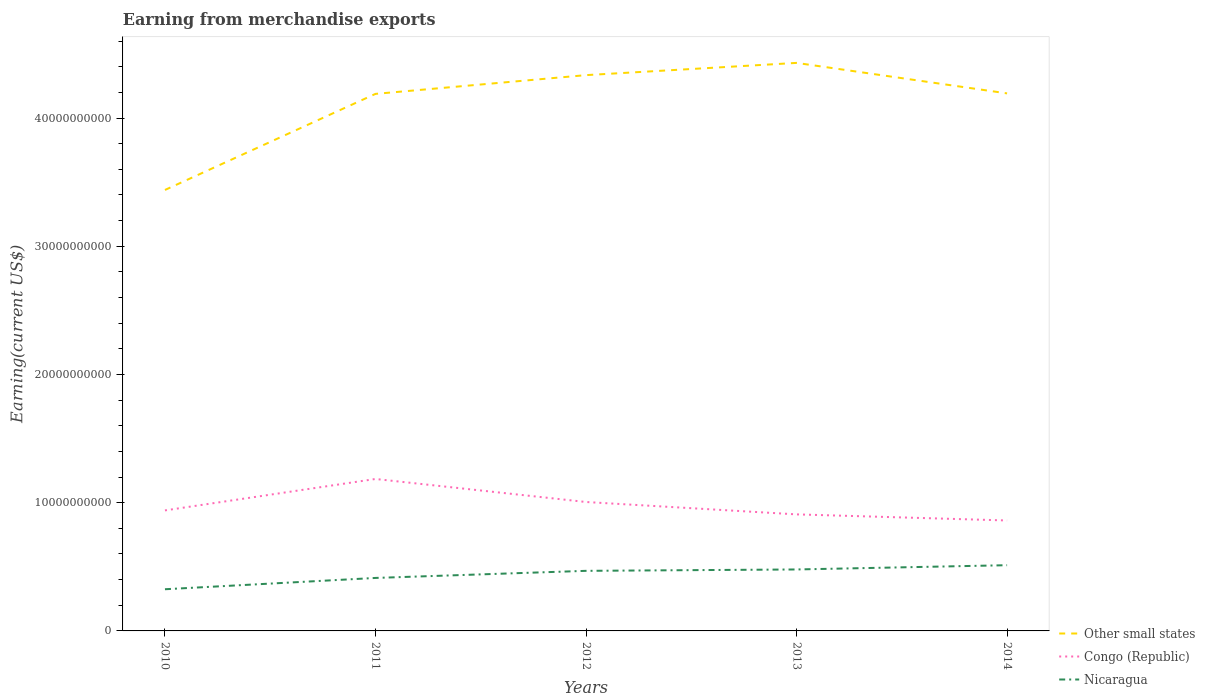How many different coloured lines are there?
Provide a short and direct response. 3. Does the line corresponding to Nicaragua intersect with the line corresponding to Congo (Republic)?
Your answer should be compact. No. Is the number of lines equal to the number of legend labels?
Offer a very short reply. Yes. Across all years, what is the maximum amount earned from merchandise exports in Nicaragua?
Provide a succinct answer. 3.25e+09. What is the total amount earned from merchandise exports in Nicaragua in the graph?
Give a very brief answer. -1.87e+09. What is the difference between the highest and the second highest amount earned from merchandise exports in Congo (Republic)?
Your answer should be very brief. 3.24e+09. Is the amount earned from merchandise exports in Congo (Republic) strictly greater than the amount earned from merchandise exports in Other small states over the years?
Make the answer very short. Yes. How many years are there in the graph?
Offer a very short reply. 5. What is the difference between two consecutive major ticks on the Y-axis?
Offer a very short reply. 1.00e+1. Are the values on the major ticks of Y-axis written in scientific E-notation?
Offer a very short reply. No. Does the graph contain any zero values?
Offer a very short reply. No. How many legend labels are there?
Make the answer very short. 3. How are the legend labels stacked?
Ensure brevity in your answer.  Vertical. What is the title of the graph?
Ensure brevity in your answer.  Earning from merchandise exports. Does "Bangladesh" appear as one of the legend labels in the graph?
Provide a short and direct response. No. What is the label or title of the Y-axis?
Make the answer very short. Earning(current US$). What is the Earning(current US$) in Other small states in 2010?
Provide a short and direct response. 3.44e+1. What is the Earning(current US$) of Congo (Republic) in 2010?
Make the answer very short. 9.40e+09. What is the Earning(current US$) of Nicaragua in 2010?
Keep it short and to the point. 3.25e+09. What is the Earning(current US$) of Other small states in 2011?
Keep it short and to the point. 4.19e+1. What is the Earning(current US$) in Congo (Republic) in 2011?
Provide a short and direct response. 1.19e+1. What is the Earning(current US$) of Nicaragua in 2011?
Give a very brief answer. 4.13e+09. What is the Earning(current US$) of Other small states in 2012?
Keep it short and to the point. 4.33e+1. What is the Earning(current US$) of Congo (Republic) in 2012?
Provide a short and direct response. 1.01e+1. What is the Earning(current US$) of Nicaragua in 2012?
Give a very brief answer. 4.69e+09. What is the Earning(current US$) in Other small states in 2013?
Your answer should be very brief. 4.43e+1. What is the Earning(current US$) in Congo (Republic) in 2013?
Your response must be concise. 9.09e+09. What is the Earning(current US$) in Nicaragua in 2013?
Make the answer very short. 4.79e+09. What is the Earning(current US$) in Other small states in 2014?
Give a very brief answer. 4.19e+1. What is the Earning(current US$) of Congo (Republic) in 2014?
Your answer should be very brief. 8.61e+09. What is the Earning(current US$) of Nicaragua in 2014?
Ensure brevity in your answer.  5.13e+09. Across all years, what is the maximum Earning(current US$) of Other small states?
Provide a short and direct response. 4.43e+1. Across all years, what is the maximum Earning(current US$) in Congo (Republic)?
Your answer should be compact. 1.19e+1. Across all years, what is the maximum Earning(current US$) in Nicaragua?
Your answer should be very brief. 5.13e+09. Across all years, what is the minimum Earning(current US$) of Other small states?
Keep it short and to the point. 3.44e+1. Across all years, what is the minimum Earning(current US$) of Congo (Republic)?
Keep it short and to the point. 8.61e+09. Across all years, what is the minimum Earning(current US$) of Nicaragua?
Provide a short and direct response. 3.25e+09. What is the total Earning(current US$) in Other small states in the graph?
Your response must be concise. 2.06e+11. What is the total Earning(current US$) in Congo (Republic) in the graph?
Provide a short and direct response. 4.90e+1. What is the total Earning(current US$) of Nicaragua in the graph?
Make the answer very short. 2.20e+1. What is the difference between the Earning(current US$) in Other small states in 2010 and that in 2011?
Offer a very short reply. -7.49e+09. What is the difference between the Earning(current US$) in Congo (Republic) in 2010 and that in 2011?
Your answer should be compact. -2.45e+09. What is the difference between the Earning(current US$) in Nicaragua in 2010 and that in 2011?
Your answer should be very brief. -8.82e+08. What is the difference between the Earning(current US$) of Other small states in 2010 and that in 2012?
Your response must be concise. -8.96e+09. What is the difference between the Earning(current US$) in Congo (Republic) in 2010 and that in 2012?
Make the answer very short. -6.55e+08. What is the difference between the Earning(current US$) of Nicaragua in 2010 and that in 2012?
Your answer should be very brief. -1.44e+09. What is the difference between the Earning(current US$) in Other small states in 2010 and that in 2013?
Your answer should be compact. -9.91e+09. What is the difference between the Earning(current US$) in Congo (Republic) in 2010 and that in 2013?
Your answer should be compact. 3.10e+08. What is the difference between the Earning(current US$) of Nicaragua in 2010 and that in 2013?
Offer a very short reply. -1.54e+09. What is the difference between the Earning(current US$) in Other small states in 2010 and that in 2014?
Keep it short and to the point. -7.53e+09. What is the difference between the Earning(current US$) in Congo (Republic) in 2010 and that in 2014?
Your answer should be compact. 7.86e+08. What is the difference between the Earning(current US$) of Nicaragua in 2010 and that in 2014?
Ensure brevity in your answer.  -1.87e+09. What is the difference between the Earning(current US$) of Other small states in 2011 and that in 2012?
Offer a very short reply. -1.46e+09. What is the difference between the Earning(current US$) in Congo (Republic) in 2011 and that in 2012?
Give a very brief answer. 1.80e+09. What is the difference between the Earning(current US$) of Nicaragua in 2011 and that in 2012?
Your response must be concise. -5.54e+08. What is the difference between the Earning(current US$) of Other small states in 2011 and that in 2013?
Your answer should be very brief. -2.42e+09. What is the difference between the Earning(current US$) in Congo (Republic) in 2011 and that in 2013?
Offer a very short reply. 2.76e+09. What is the difference between the Earning(current US$) in Nicaragua in 2011 and that in 2013?
Give a very brief answer. -6.61e+08. What is the difference between the Earning(current US$) in Other small states in 2011 and that in 2014?
Give a very brief answer. -3.86e+07. What is the difference between the Earning(current US$) of Congo (Republic) in 2011 and that in 2014?
Ensure brevity in your answer.  3.24e+09. What is the difference between the Earning(current US$) of Nicaragua in 2011 and that in 2014?
Ensure brevity in your answer.  -9.93e+08. What is the difference between the Earning(current US$) in Other small states in 2012 and that in 2013?
Your answer should be very brief. -9.54e+08. What is the difference between the Earning(current US$) in Congo (Republic) in 2012 and that in 2013?
Give a very brief answer. 9.65e+08. What is the difference between the Earning(current US$) of Nicaragua in 2012 and that in 2013?
Offer a very short reply. -1.08e+08. What is the difference between the Earning(current US$) of Other small states in 2012 and that in 2014?
Provide a short and direct response. 1.42e+09. What is the difference between the Earning(current US$) of Congo (Republic) in 2012 and that in 2014?
Provide a short and direct response. 1.44e+09. What is the difference between the Earning(current US$) in Nicaragua in 2012 and that in 2014?
Your answer should be very brief. -4.40e+08. What is the difference between the Earning(current US$) of Other small states in 2013 and that in 2014?
Provide a short and direct response. 2.38e+09. What is the difference between the Earning(current US$) of Congo (Republic) in 2013 and that in 2014?
Offer a terse response. 4.76e+08. What is the difference between the Earning(current US$) of Nicaragua in 2013 and that in 2014?
Your answer should be compact. -3.32e+08. What is the difference between the Earning(current US$) of Other small states in 2010 and the Earning(current US$) of Congo (Republic) in 2011?
Your response must be concise. 2.25e+1. What is the difference between the Earning(current US$) in Other small states in 2010 and the Earning(current US$) in Nicaragua in 2011?
Offer a very short reply. 3.03e+1. What is the difference between the Earning(current US$) in Congo (Republic) in 2010 and the Earning(current US$) in Nicaragua in 2011?
Make the answer very short. 5.27e+09. What is the difference between the Earning(current US$) of Other small states in 2010 and the Earning(current US$) of Congo (Republic) in 2012?
Offer a very short reply. 2.43e+1. What is the difference between the Earning(current US$) of Other small states in 2010 and the Earning(current US$) of Nicaragua in 2012?
Offer a terse response. 2.97e+1. What is the difference between the Earning(current US$) of Congo (Republic) in 2010 and the Earning(current US$) of Nicaragua in 2012?
Keep it short and to the point. 4.71e+09. What is the difference between the Earning(current US$) of Other small states in 2010 and the Earning(current US$) of Congo (Republic) in 2013?
Your answer should be compact. 2.53e+1. What is the difference between the Earning(current US$) of Other small states in 2010 and the Earning(current US$) of Nicaragua in 2013?
Your answer should be compact. 2.96e+1. What is the difference between the Earning(current US$) in Congo (Republic) in 2010 and the Earning(current US$) in Nicaragua in 2013?
Make the answer very short. 4.61e+09. What is the difference between the Earning(current US$) of Other small states in 2010 and the Earning(current US$) of Congo (Republic) in 2014?
Give a very brief answer. 2.58e+1. What is the difference between the Earning(current US$) in Other small states in 2010 and the Earning(current US$) in Nicaragua in 2014?
Provide a short and direct response. 2.93e+1. What is the difference between the Earning(current US$) in Congo (Republic) in 2010 and the Earning(current US$) in Nicaragua in 2014?
Give a very brief answer. 4.27e+09. What is the difference between the Earning(current US$) in Other small states in 2011 and the Earning(current US$) in Congo (Republic) in 2012?
Your response must be concise. 3.18e+1. What is the difference between the Earning(current US$) of Other small states in 2011 and the Earning(current US$) of Nicaragua in 2012?
Offer a very short reply. 3.72e+1. What is the difference between the Earning(current US$) in Congo (Republic) in 2011 and the Earning(current US$) in Nicaragua in 2012?
Offer a very short reply. 7.16e+09. What is the difference between the Earning(current US$) in Other small states in 2011 and the Earning(current US$) in Congo (Republic) in 2013?
Give a very brief answer. 3.28e+1. What is the difference between the Earning(current US$) of Other small states in 2011 and the Earning(current US$) of Nicaragua in 2013?
Give a very brief answer. 3.71e+1. What is the difference between the Earning(current US$) of Congo (Republic) in 2011 and the Earning(current US$) of Nicaragua in 2013?
Offer a terse response. 7.06e+09. What is the difference between the Earning(current US$) in Other small states in 2011 and the Earning(current US$) in Congo (Republic) in 2014?
Ensure brevity in your answer.  3.33e+1. What is the difference between the Earning(current US$) in Other small states in 2011 and the Earning(current US$) in Nicaragua in 2014?
Give a very brief answer. 3.68e+1. What is the difference between the Earning(current US$) in Congo (Republic) in 2011 and the Earning(current US$) in Nicaragua in 2014?
Your answer should be very brief. 6.73e+09. What is the difference between the Earning(current US$) in Other small states in 2012 and the Earning(current US$) in Congo (Republic) in 2013?
Keep it short and to the point. 3.43e+1. What is the difference between the Earning(current US$) in Other small states in 2012 and the Earning(current US$) in Nicaragua in 2013?
Make the answer very short. 3.86e+1. What is the difference between the Earning(current US$) in Congo (Republic) in 2012 and the Earning(current US$) in Nicaragua in 2013?
Ensure brevity in your answer.  5.26e+09. What is the difference between the Earning(current US$) of Other small states in 2012 and the Earning(current US$) of Congo (Republic) in 2014?
Offer a terse response. 3.47e+1. What is the difference between the Earning(current US$) in Other small states in 2012 and the Earning(current US$) in Nicaragua in 2014?
Keep it short and to the point. 3.82e+1. What is the difference between the Earning(current US$) of Congo (Republic) in 2012 and the Earning(current US$) of Nicaragua in 2014?
Offer a very short reply. 4.93e+09. What is the difference between the Earning(current US$) of Other small states in 2013 and the Earning(current US$) of Congo (Republic) in 2014?
Your answer should be very brief. 3.57e+1. What is the difference between the Earning(current US$) of Other small states in 2013 and the Earning(current US$) of Nicaragua in 2014?
Your response must be concise. 3.92e+1. What is the difference between the Earning(current US$) of Congo (Republic) in 2013 and the Earning(current US$) of Nicaragua in 2014?
Give a very brief answer. 3.96e+09. What is the average Earning(current US$) in Other small states per year?
Your response must be concise. 4.12e+1. What is the average Earning(current US$) of Congo (Republic) per year?
Provide a short and direct response. 9.80e+09. What is the average Earning(current US$) in Nicaragua per year?
Your answer should be very brief. 4.40e+09. In the year 2010, what is the difference between the Earning(current US$) of Other small states and Earning(current US$) of Congo (Republic)?
Keep it short and to the point. 2.50e+1. In the year 2010, what is the difference between the Earning(current US$) in Other small states and Earning(current US$) in Nicaragua?
Offer a terse response. 3.11e+1. In the year 2010, what is the difference between the Earning(current US$) in Congo (Republic) and Earning(current US$) in Nicaragua?
Give a very brief answer. 6.15e+09. In the year 2011, what is the difference between the Earning(current US$) in Other small states and Earning(current US$) in Congo (Republic)?
Give a very brief answer. 3.00e+1. In the year 2011, what is the difference between the Earning(current US$) in Other small states and Earning(current US$) in Nicaragua?
Provide a short and direct response. 3.78e+1. In the year 2011, what is the difference between the Earning(current US$) in Congo (Republic) and Earning(current US$) in Nicaragua?
Provide a short and direct response. 7.72e+09. In the year 2012, what is the difference between the Earning(current US$) in Other small states and Earning(current US$) in Congo (Republic)?
Your response must be concise. 3.33e+1. In the year 2012, what is the difference between the Earning(current US$) of Other small states and Earning(current US$) of Nicaragua?
Your answer should be compact. 3.87e+1. In the year 2012, what is the difference between the Earning(current US$) in Congo (Republic) and Earning(current US$) in Nicaragua?
Your response must be concise. 5.37e+09. In the year 2013, what is the difference between the Earning(current US$) in Other small states and Earning(current US$) in Congo (Republic)?
Make the answer very short. 3.52e+1. In the year 2013, what is the difference between the Earning(current US$) in Other small states and Earning(current US$) in Nicaragua?
Give a very brief answer. 3.95e+1. In the year 2013, what is the difference between the Earning(current US$) of Congo (Republic) and Earning(current US$) of Nicaragua?
Give a very brief answer. 4.30e+09. In the year 2014, what is the difference between the Earning(current US$) of Other small states and Earning(current US$) of Congo (Republic)?
Keep it short and to the point. 3.33e+1. In the year 2014, what is the difference between the Earning(current US$) in Other small states and Earning(current US$) in Nicaragua?
Offer a very short reply. 3.68e+1. In the year 2014, what is the difference between the Earning(current US$) in Congo (Republic) and Earning(current US$) in Nicaragua?
Offer a very short reply. 3.49e+09. What is the ratio of the Earning(current US$) of Other small states in 2010 to that in 2011?
Keep it short and to the point. 0.82. What is the ratio of the Earning(current US$) in Congo (Republic) in 2010 to that in 2011?
Provide a short and direct response. 0.79. What is the ratio of the Earning(current US$) of Nicaragua in 2010 to that in 2011?
Make the answer very short. 0.79. What is the ratio of the Earning(current US$) in Other small states in 2010 to that in 2012?
Provide a short and direct response. 0.79. What is the ratio of the Earning(current US$) of Congo (Republic) in 2010 to that in 2012?
Provide a short and direct response. 0.93. What is the ratio of the Earning(current US$) in Nicaragua in 2010 to that in 2012?
Give a very brief answer. 0.69. What is the ratio of the Earning(current US$) of Other small states in 2010 to that in 2013?
Provide a short and direct response. 0.78. What is the ratio of the Earning(current US$) in Congo (Republic) in 2010 to that in 2013?
Make the answer very short. 1.03. What is the ratio of the Earning(current US$) in Nicaragua in 2010 to that in 2013?
Give a very brief answer. 0.68. What is the ratio of the Earning(current US$) of Other small states in 2010 to that in 2014?
Offer a terse response. 0.82. What is the ratio of the Earning(current US$) in Congo (Republic) in 2010 to that in 2014?
Ensure brevity in your answer.  1.09. What is the ratio of the Earning(current US$) of Nicaragua in 2010 to that in 2014?
Provide a short and direct response. 0.63. What is the ratio of the Earning(current US$) of Other small states in 2011 to that in 2012?
Your answer should be compact. 0.97. What is the ratio of the Earning(current US$) of Congo (Republic) in 2011 to that in 2012?
Provide a short and direct response. 1.18. What is the ratio of the Earning(current US$) in Nicaragua in 2011 to that in 2012?
Offer a very short reply. 0.88. What is the ratio of the Earning(current US$) in Other small states in 2011 to that in 2013?
Provide a short and direct response. 0.95. What is the ratio of the Earning(current US$) in Congo (Republic) in 2011 to that in 2013?
Ensure brevity in your answer.  1.3. What is the ratio of the Earning(current US$) in Nicaragua in 2011 to that in 2013?
Make the answer very short. 0.86. What is the ratio of the Earning(current US$) of Other small states in 2011 to that in 2014?
Offer a terse response. 1. What is the ratio of the Earning(current US$) in Congo (Republic) in 2011 to that in 2014?
Your answer should be very brief. 1.38. What is the ratio of the Earning(current US$) of Nicaragua in 2011 to that in 2014?
Offer a terse response. 0.81. What is the ratio of the Earning(current US$) in Other small states in 2012 to that in 2013?
Give a very brief answer. 0.98. What is the ratio of the Earning(current US$) in Congo (Republic) in 2012 to that in 2013?
Offer a terse response. 1.11. What is the ratio of the Earning(current US$) of Nicaragua in 2012 to that in 2013?
Make the answer very short. 0.98. What is the ratio of the Earning(current US$) of Other small states in 2012 to that in 2014?
Offer a terse response. 1.03. What is the ratio of the Earning(current US$) in Congo (Republic) in 2012 to that in 2014?
Ensure brevity in your answer.  1.17. What is the ratio of the Earning(current US$) in Nicaragua in 2012 to that in 2014?
Provide a short and direct response. 0.91. What is the ratio of the Earning(current US$) in Other small states in 2013 to that in 2014?
Your answer should be very brief. 1.06. What is the ratio of the Earning(current US$) of Congo (Republic) in 2013 to that in 2014?
Keep it short and to the point. 1.06. What is the ratio of the Earning(current US$) in Nicaragua in 2013 to that in 2014?
Provide a succinct answer. 0.94. What is the difference between the highest and the second highest Earning(current US$) in Other small states?
Your answer should be compact. 9.54e+08. What is the difference between the highest and the second highest Earning(current US$) in Congo (Republic)?
Provide a succinct answer. 1.80e+09. What is the difference between the highest and the second highest Earning(current US$) of Nicaragua?
Ensure brevity in your answer.  3.32e+08. What is the difference between the highest and the lowest Earning(current US$) in Other small states?
Offer a terse response. 9.91e+09. What is the difference between the highest and the lowest Earning(current US$) in Congo (Republic)?
Provide a succinct answer. 3.24e+09. What is the difference between the highest and the lowest Earning(current US$) in Nicaragua?
Offer a terse response. 1.87e+09. 